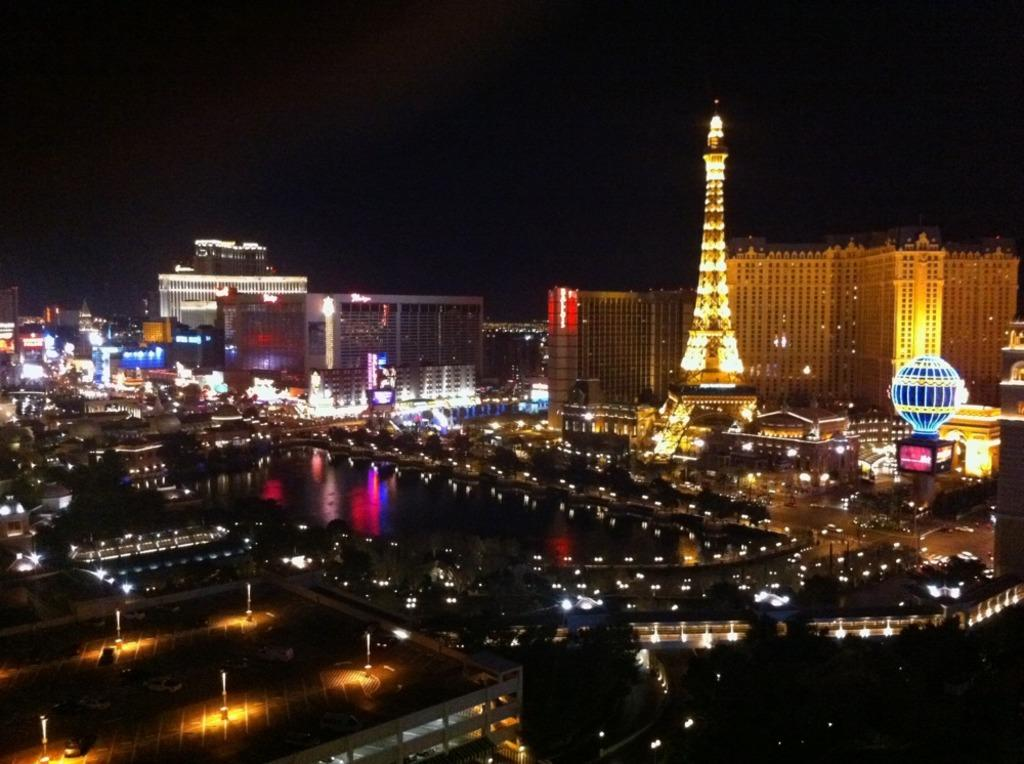What type of structures can be seen in the image? There are buildings and a tower in the image. Are there any illuminated objects in the image? Yes, there are lights visible in the image. How would you describe the overall lighting in the image? The background of the image is dark. How many girls are playing volleyball in the image? There are no girls or volleyball present in the image. What type of meat can be seen hanging from the tower in the image? There is no meat or indication of any food items in the image. 